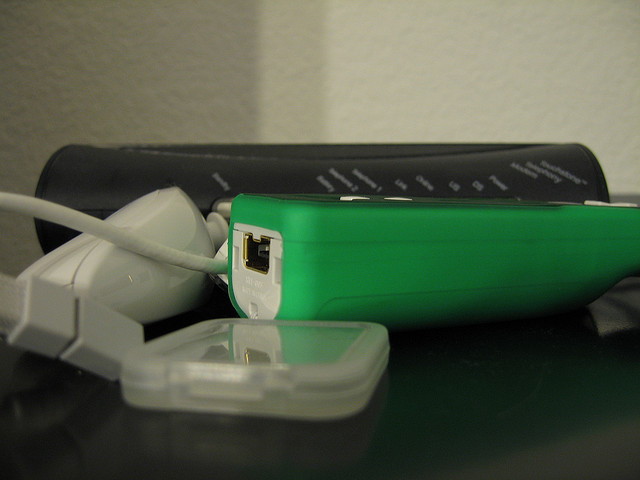<image>Which handle is blue? There is no blue handle in the image. Which handle is blue? I don't know which handle is blue. 